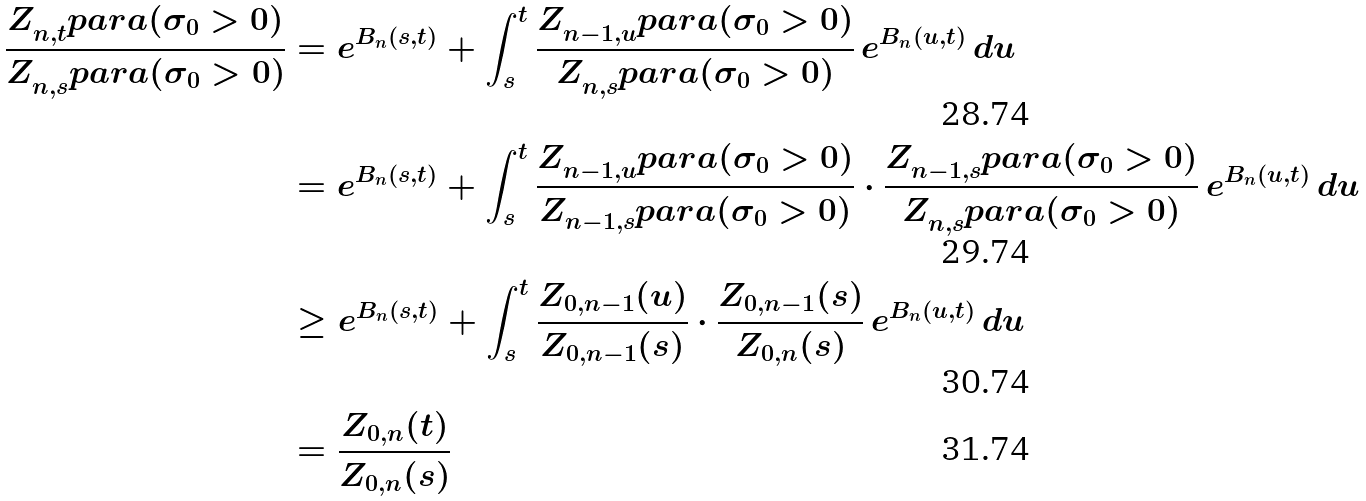<formula> <loc_0><loc_0><loc_500><loc_500>\frac { Z _ { n , t } ^ { \ } p a r a ( \sigma _ { 0 } > 0 ) } { Z _ { n , s } ^ { \ } p a r a ( \sigma _ { 0 } > 0 ) } & = e ^ { B _ { n } ( s , t ) } + \int _ { s } ^ { t } \frac { Z _ { n - 1 , u } ^ { \ } p a r a ( \sigma _ { 0 } > 0 ) } { Z _ { n , s } ^ { \ } p a r a ( \sigma _ { 0 } > 0 ) } \, e ^ { B _ { n } ( u , t ) } \, d u \\ & = e ^ { B _ { n } ( s , t ) } + \int _ { s } ^ { t } \frac { Z _ { n - 1 , u } ^ { \ } p a r a ( \sigma _ { 0 } > 0 ) } { Z _ { n - 1 , s } ^ { \ } p a r a ( \sigma _ { 0 } > 0 ) } \cdot \frac { Z _ { n - 1 , s } ^ { \ } p a r a ( \sigma _ { 0 } > 0 ) } { Z _ { n , s } ^ { \ } p a r a ( \sigma _ { 0 } > 0 ) } \, e ^ { B _ { n } ( u , t ) } \, d u \\ & \geq e ^ { B _ { n } ( s , t ) } + \int _ { s } ^ { t } \frac { Z _ { 0 , n - 1 } ( u ) } { Z _ { 0 , n - 1 } ( s ) } \cdot \frac { Z _ { 0 , n - 1 } ( s ) } { Z _ { 0 , n } ( s ) } \, e ^ { B _ { n } ( u , t ) } \, d u \\ & = \frac { Z _ { 0 , n } ( t ) } { Z _ { 0 , n } ( s ) }</formula> 